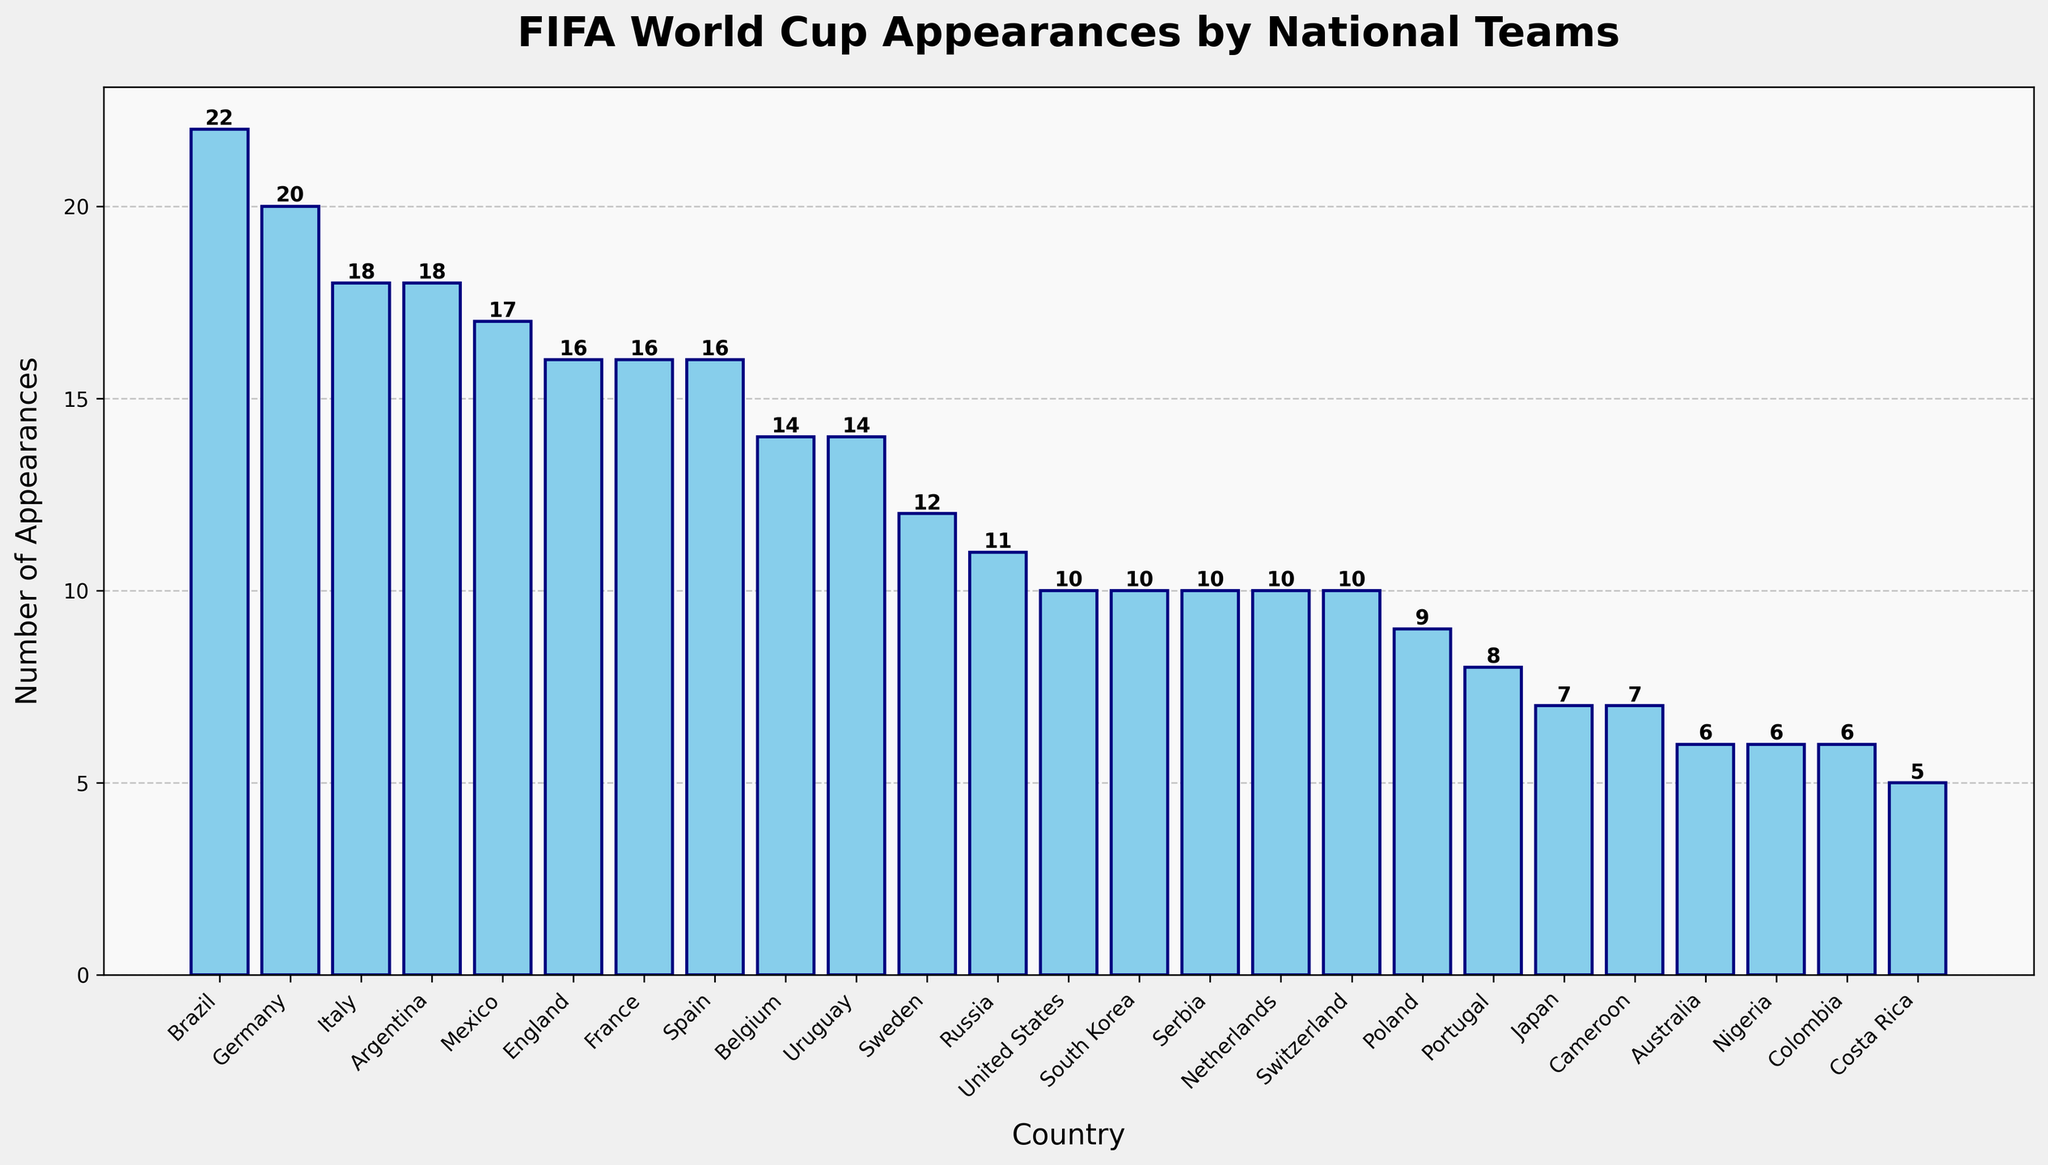What's the total number of FIFA World Cup appearances for Brazil, Germany, and Italy? First, identify the number of appearances for each country: Brazil (22), Germany (20), and Italy (18). Then, sum these values: 22 + 20 + 18 = 60.
Answer: 60 Which country has more FIFA World Cup appearances, France or Spain? Both France and Spain have 16 appearances each. Since their counts are equal, neither has more appearances than the other.
Answer: Neither Is the number of FIFA World Cup appearances by Argentina closer to that of Germany or Mexico? Argentina has 18 appearances. Germany has 20 appearances, and Mexico has 17 appearances. The difference between Argentina and Germany is 20 - 18 = 2, while the difference between Argentina and Mexico is 18 - 17 = 1. Since 1 is smaller than 2, Argentina's count is closer to Mexico's.
Answer: Mexico Which country has the highest number of FIFA World Cup appearances on the chart? Identify the bar with the greatest height, which corresponds to Brazil with 22 appearances.
Answer: Brazil What is the sum of FIFA World Cup appearances for all the teams with more than 15 appearances? Identify the countries with more than 15 appearances: Brazil (22), Germany (20), Italy (18), Argentina (18), Mexico (17), England (16), France (16), and Spain (16). Sum these values: 22 + 20 + 18 + 18 + 17 + 16 + 16 + 16 = 143.
Answer: 143 